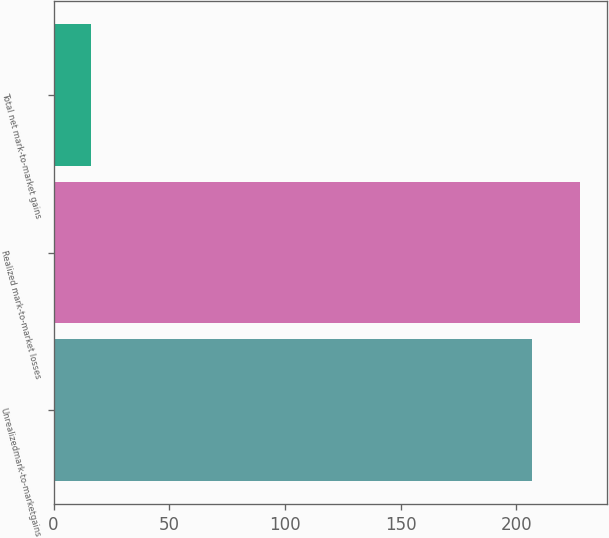<chart> <loc_0><loc_0><loc_500><loc_500><bar_chart><fcel>Unrealizedmark-to-marketgains<fcel>Realized mark-to-market losses<fcel>Total net mark-to-market gains<nl><fcel>207<fcel>227.7<fcel>16<nl></chart> 